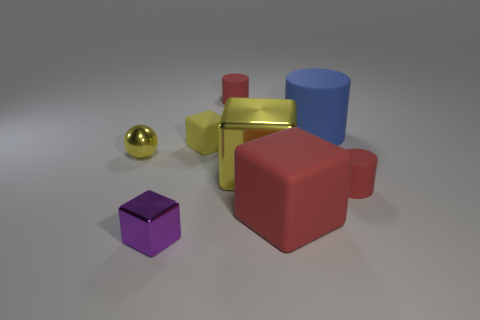Subtract all red matte cylinders. How many cylinders are left? 1 Add 1 big yellow objects. How many objects exist? 9 Subtract all red cylinders. How many cylinders are left? 1 Subtract 1 spheres. How many spheres are left? 0 Subtract all spheres. How many objects are left? 7 Subtract all purple cylinders. Subtract all gray balls. How many cylinders are left? 3 Subtract all red balls. How many red cylinders are left? 2 Subtract all tiny metal blocks. Subtract all tiny cylinders. How many objects are left? 5 Add 4 big blocks. How many big blocks are left? 6 Add 7 big green matte objects. How many big green matte objects exist? 7 